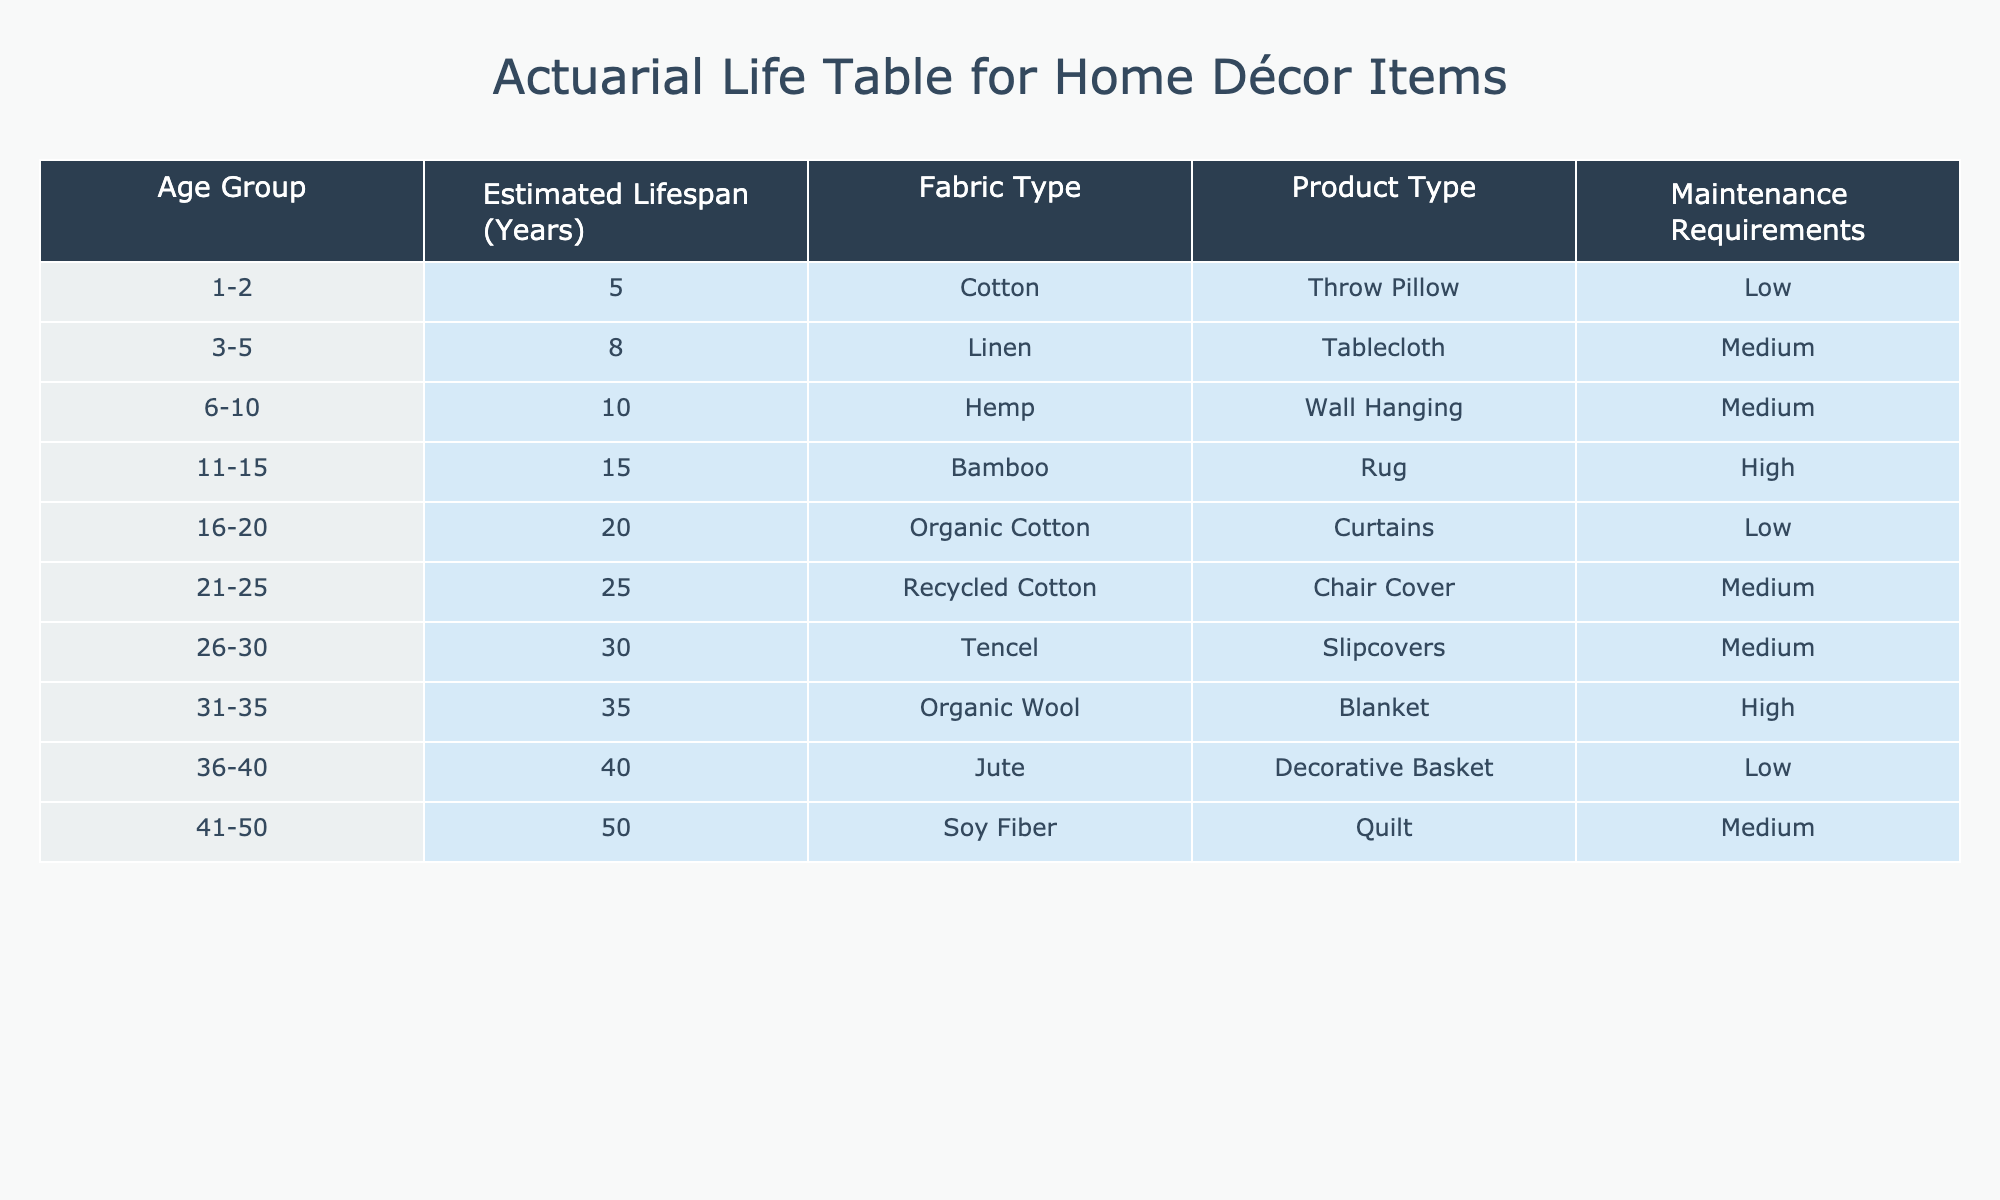What is the estimated lifespan of a throw pillow made from cotton? The table indicates that for the age group of 1-2 years, the estimated lifespan of a throw pillow made from cotton is 5 years.
Answer: 5 years What is the maximum estimated lifespan of an item in the table? By looking at the "Estimated Lifespan (Years)" column, the maximum value is 50 years, which corresponds to the quilt made from soy fiber in the age group of 41-50 years.
Answer: 50 years Are organic wool blankets high maintenance? The maintenance requirement for the organic wool blanket is noted as high in the table, confirming that it is indeed high maintenance.
Answer: Yes What is the average estimated lifespan of items classified under low maintenance? The low maintenance items are: throw pillow (5 years), curtains (20 years), and decorative basket (40 years). Summing these gives 5 + 20 + 40 = 65 years. There are 3 items, so the average is 65/3 = 21.67 years.
Answer: 21.67 years Which fabric type has the longest estimated lifespan? The fabric type with the longest estimated lifespan is soy fiber, with an estimated lifespan of 50 years for the quilt in the 41-50 age group.
Answer: Soy fiber How many product types have an estimated lifespan of 30 years or more? The table shows that the slipcovers (30 years), quilt (50 years), and chair cover (25 years) fall into this category. Therefore, there are three product types (slipcovers, quilt, chair cover) that meet this criterion.
Answer: 3 product types What is the estimated lifespan difference between the longest (soy fiber quilt) and the shortest (cotton throw pillow) item? The longest estimated lifespan is 50 years (soy fiber quilt), and the shortest is 5 years (cotton throw pillow). The difference is 50 - 5 = 45 years.
Answer: 45 years Is there a product type that only requires low maintenance? Yes, the throw pillow and decorative basket are both classified as low maintenance products.
Answer: Yes 